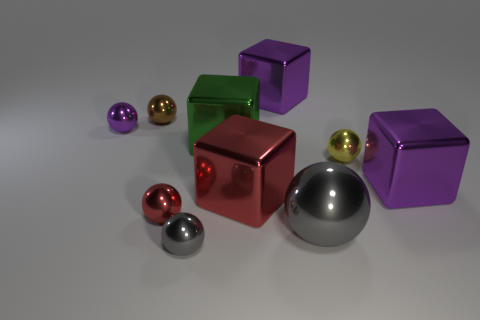Does the large green thing have the same shape as the small brown object?
Provide a succinct answer. No. What size is the purple metallic cube to the left of the big block on the right side of the gray shiny sphere on the right side of the green thing?
Ensure brevity in your answer.  Large. There is a purple cube left of the yellow object; are there any large green metal objects in front of it?
Keep it short and to the point. Yes. How many red metal objects are behind the big purple block that is on the right side of the small ball that is right of the small gray ball?
Provide a succinct answer. 0. There is a object that is on the right side of the small purple thing and to the left of the small red metal sphere; what is its color?
Your response must be concise. Brown. How many tiny shiny balls are the same color as the big shiny ball?
Your response must be concise. 1. How many cubes are either purple things or metallic objects?
Your response must be concise. 4. What color is the ball that is the same size as the green thing?
Ensure brevity in your answer.  Gray. Is there a purple shiny object that is to the right of the cube that is right of the big gray metal object that is in front of the small yellow shiny thing?
Give a very brief answer. No. The red metallic block is what size?
Provide a short and direct response. Large. 